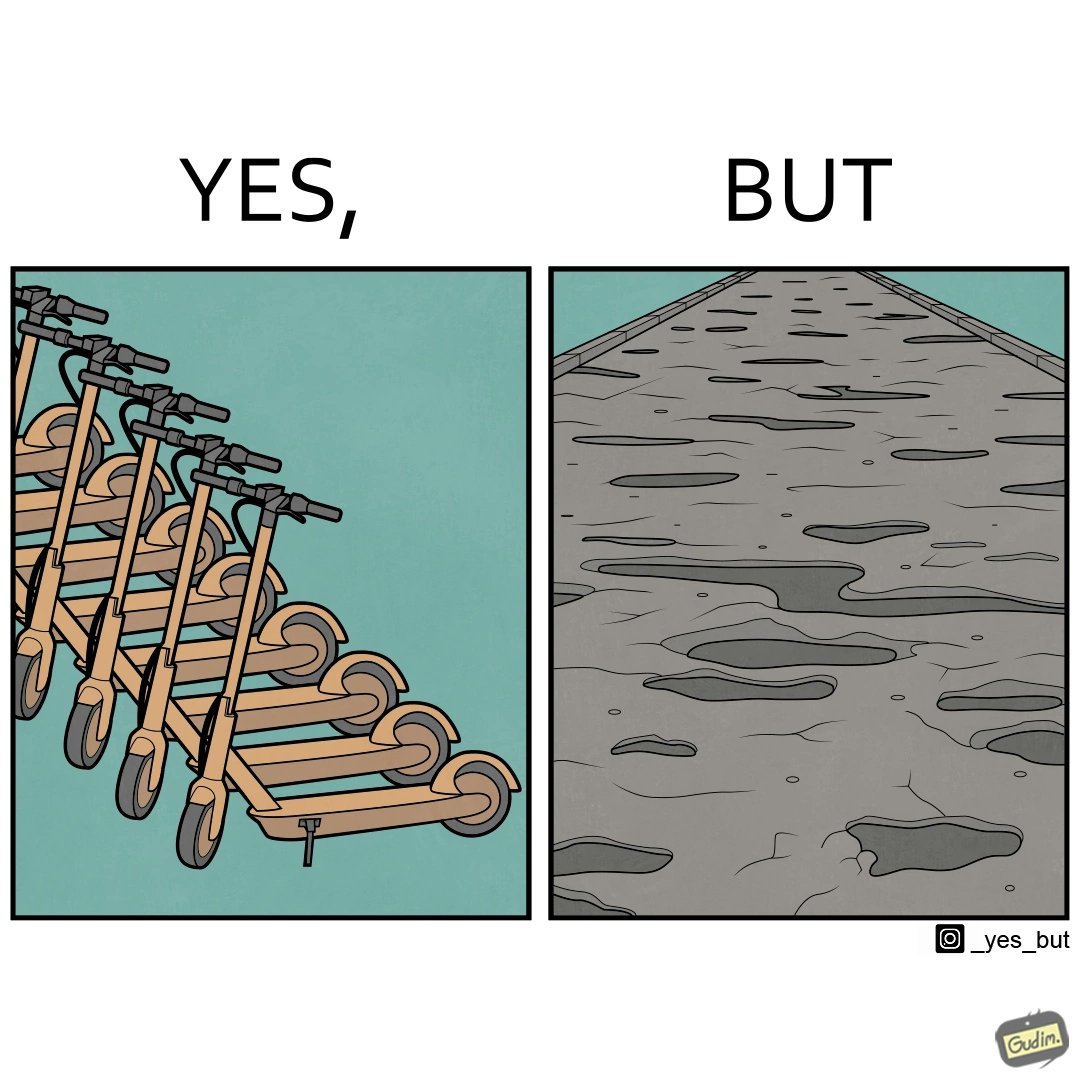What does this image depict? The image is ironic, because even after when the skateboard scooters are available for someone to ride but the road has many potholes that it is not suitable to ride the scooters on such roads 